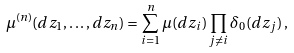Convert formula to latex. <formula><loc_0><loc_0><loc_500><loc_500>\mu ^ { ( n ) } ( d z _ { 1 } , \dots , d z _ { n } ) = \sum _ { i = 1 } ^ { n } \mu ( d z _ { i } ) \prod _ { j \neq i } \delta _ { 0 } ( d z _ { j } ) \, ,</formula> 